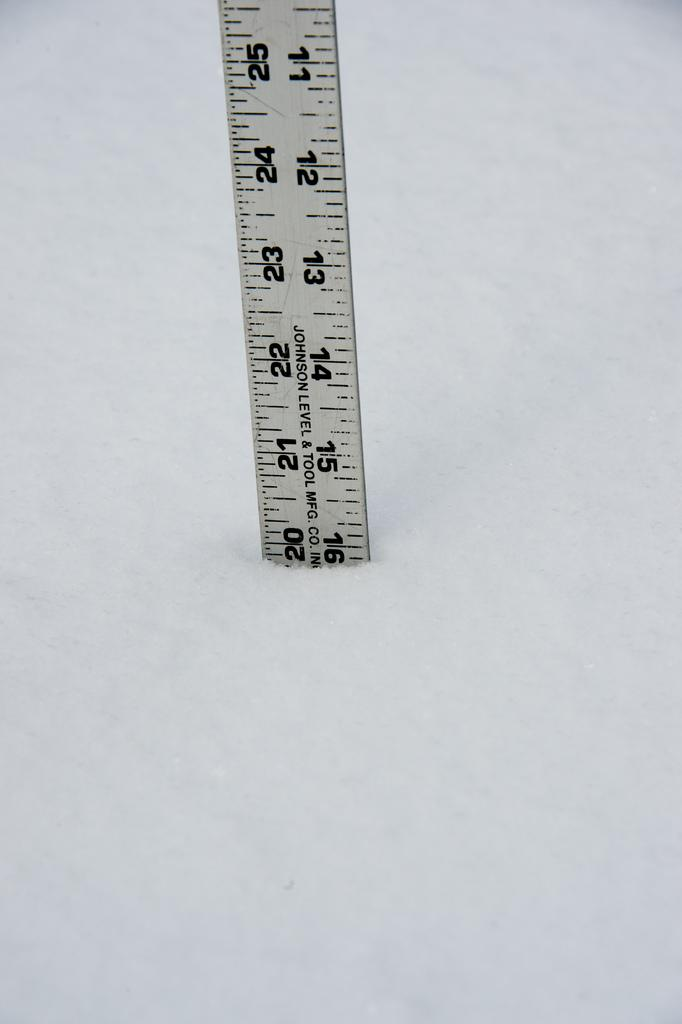<image>
Give a short and clear explanation of the subsequent image. a ruler that had the number 21 on it 